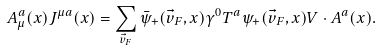<formula> <loc_0><loc_0><loc_500><loc_500>A ^ { a } _ { \mu } ( x ) J ^ { \mu a } ( x ) = \sum _ { \vec { v } _ { F } } \bar { \psi } _ { + } ( \vec { v } _ { F } , x ) \gamma ^ { 0 } T ^ { a } \psi _ { + } ( \vec { v } _ { F } , x ) V \cdot A ^ { a } ( x ) .</formula> 